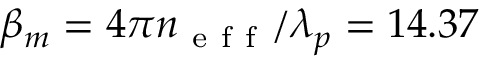<formula> <loc_0><loc_0><loc_500><loc_500>\beta _ { m } = 4 \pi n _ { e f f } / \lambda _ { p } = 1 4 . 3 7</formula> 